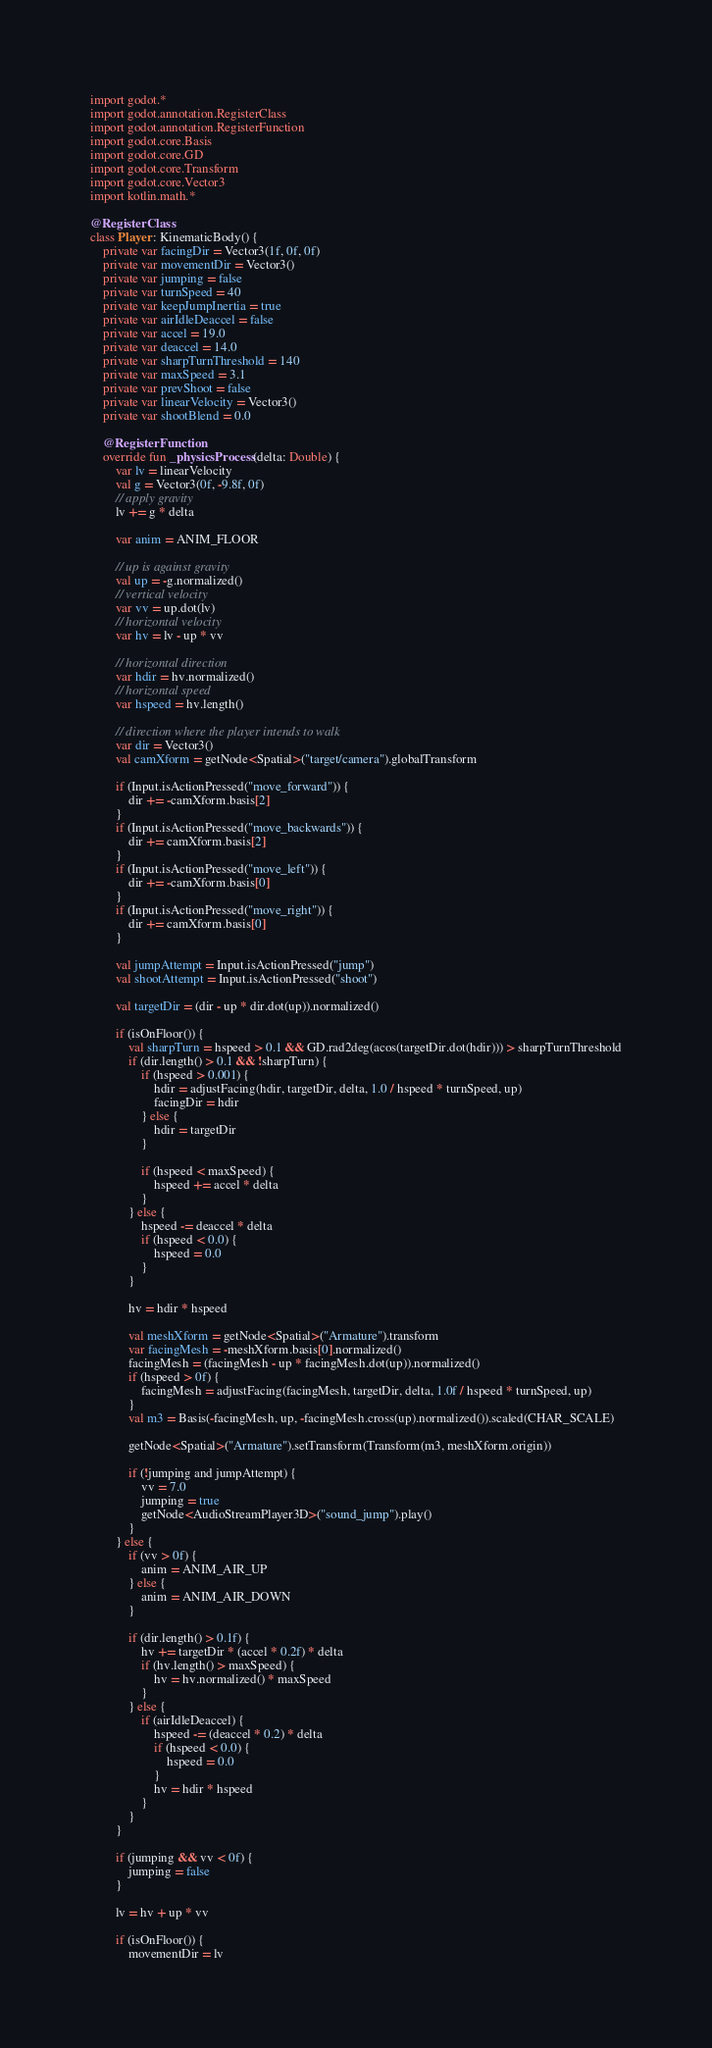<code> <loc_0><loc_0><loc_500><loc_500><_Kotlin_>import godot.*
import godot.annotation.RegisterClass
import godot.annotation.RegisterFunction
import godot.core.Basis
import godot.core.GD
import godot.core.Transform
import godot.core.Vector3
import kotlin.math.*

@RegisterClass
class Player : KinematicBody() {
    private var facingDir = Vector3(1f, 0f, 0f)
    private var movementDir = Vector3()
    private var jumping = false
    private var turnSpeed = 40
    private var keepJumpInertia = true
    private var airIdleDeaccel = false
    private var accel = 19.0
    private var deaccel = 14.0
    private var sharpTurnThreshold = 140
    private var maxSpeed = 3.1
    private var prevShoot = false
    private var linearVelocity = Vector3()
    private var shootBlend = 0.0

    @RegisterFunction
    override fun _physicsProcess(delta: Double) {
        var lv = linearVelocity
        val g = Vector3(0f, -9.8f, 0f)
        // apply gravity
        lv += g * delta

        var anim = ANIM_FLOOR

        // up is against gravity
        val up = -g.normalized()
        // vertical velocity
        var vv = up.dot(lv)
        // horizontal velocity
        var hv = lv - up * vv

        // horizontal direction
        var hdir = hv.normalized()
        // horizontal speed
        var hspeed = hv.length()

        // direction where the player intends to walk
        var dir = Vector3()
        val camXform = getNode<Spatial>("target/camera").globalTransform

        if (Input.isActionPressed("move_forward")) {
            dir += -camXform.basis[2]
        }
        if (Input.isActionPressed("move_backwards")) {
            dir += camXform.basis[2]
        }
        if (Input.isActionPressed("move_left")) {
            dir += -camXform.basis[0]
        }
        if (Input.isActionPressed("move_right")) {
            dir += camXform.basis[0]
        }

        val jumpAttempt = Input.isActionPressed("jump")
        val shootAttempt = Input.isActionPressed("shoot")

        val targetDir = (dir - up * dir.dot(up)).normalized()

        if (isOnFloor()) {
            val sharpTurn = hspeed > 0.1 && GD.rad2deg(acos(targetDir.dot(hdir))) > sharpTurnThreshold
            if (dir.length() > 0.1 && !sharpTurn) {
                if (hspeed > 0.001) {
                    hdir = adjustFacing(hdir, targetDir, delta, 1.0 / hspeed * turnSpeed, up)
                    facingDir = hdir
                } else {
                    hdir = targetDir
                }

                if (hspeed < maxSpeed) {
                    hspeed += accel * delta
                }
            } else {
                hspeed -= deaccel * delta
                if (hspeed < 0.0) {
                    hspeed = 0.0
                }
            }

            hv = hdir * hspeed

            val meshXform = getNode<Spatial>("Armature").transform
            var facingMesh = -meshXform.basis[0].normalized()
            facingMesh = (facingMesh - up * facingMesh.dot(up)).normalized()
            if (hspeed > 0f) {
                facingMesh = adjustFacing(facingMesh, targetDir, delta, 1.0f / hspeed * turnSpeed, up)
            }
            val m3 = Basis(-facingMesh, up, -facingMesh.cross(up).normalized()).scaled(CHAR_SCALE)

            getNode<Spatial>("Armature").setTransform(Transform(m3, meshXform.origin))

            if (!jumping and jumpAttempt) {
                vv = 7.0
                jumping = true
                getNode<AudioStreamPlayer3D>("sound_jump").play()
            }
        } else {
            if (vv > 0f) {
                anim = ANIM_AIR_UP
            } else {
                anim = ANIM_AIR_DOWN
            }

            if (dir.length() > 0.1f) {
                hv += targetDir * (accel * 0.2f) * delta
                if (hv.length() > maxSpeed) {
                    hv = hv.normalized() * maxSpeed
                }
            } else {
                if (airIdleDeaccel) {
                    hspeed -= (deaccel * 0.2) * delta
                    if (hspeed < 0.0) {
                        hspeed = 0.0
                    }
                    hv = hdir * hspeed
                }
            }
        }

        if (jumping && vv < 0f) {
            jumping = false
        }

        lv = hv + up * vv

        if (isOnFloor()) {
            movementDir = lv</code> 